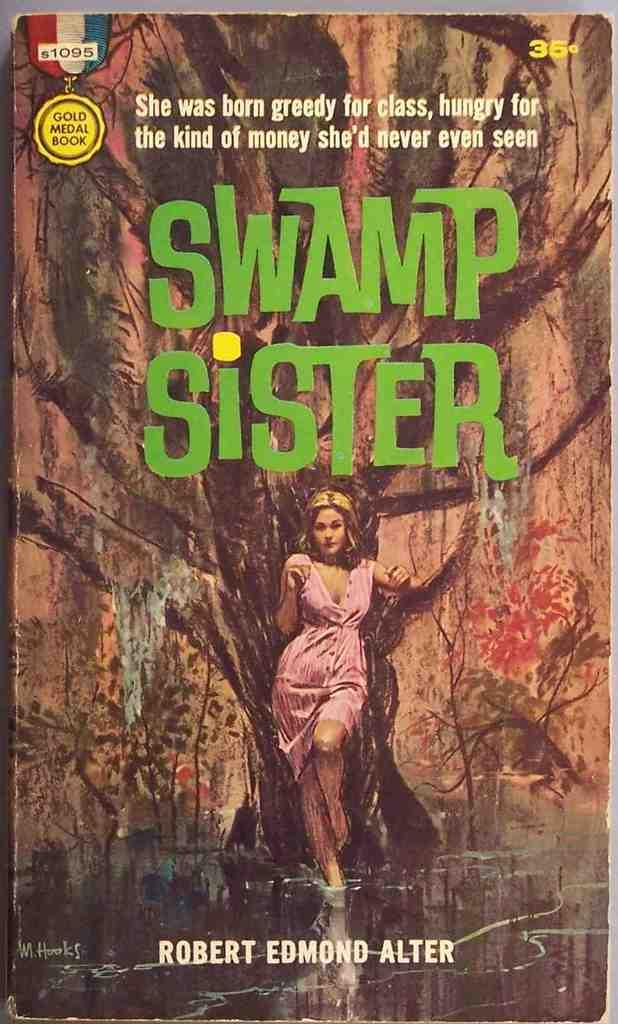<image>
Give a short and clear explanation of the subsequent image. The Swamp Sister book was written about a greedy woman wanting money. 